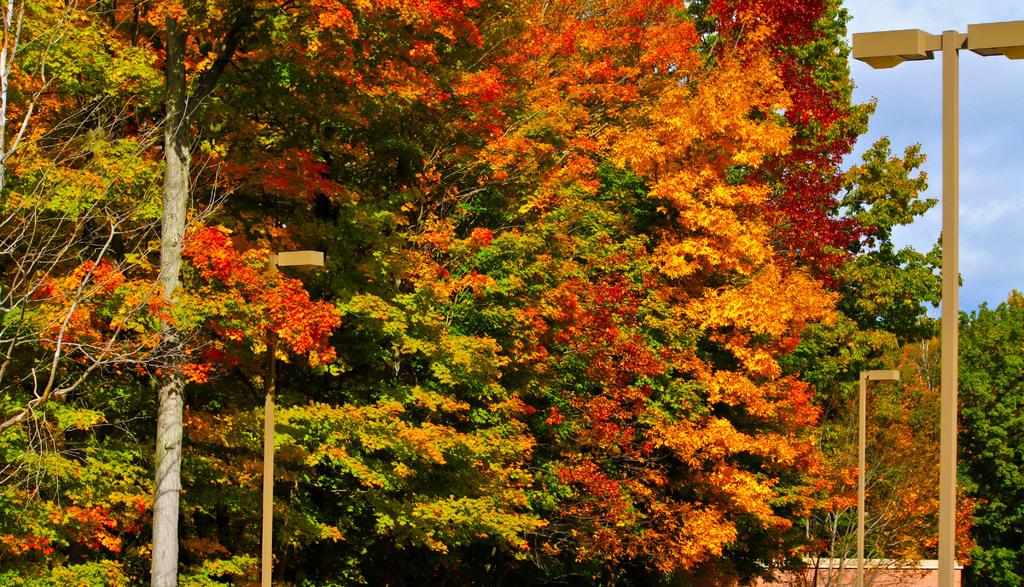What type of natural elements can be seen in the image? There are many trees in the image. What man-made structures are present in the image? There are light poles in the image. What is visible in the background of the image? The sky is visible in the image. How would you describe the appearance of the sky in the image? The sky appears to be cloudy and pale blue. How many firemen are visible in the image? There are no firemen present in the image. What type of star can be seen in the image? There are no stars visible in the image. 